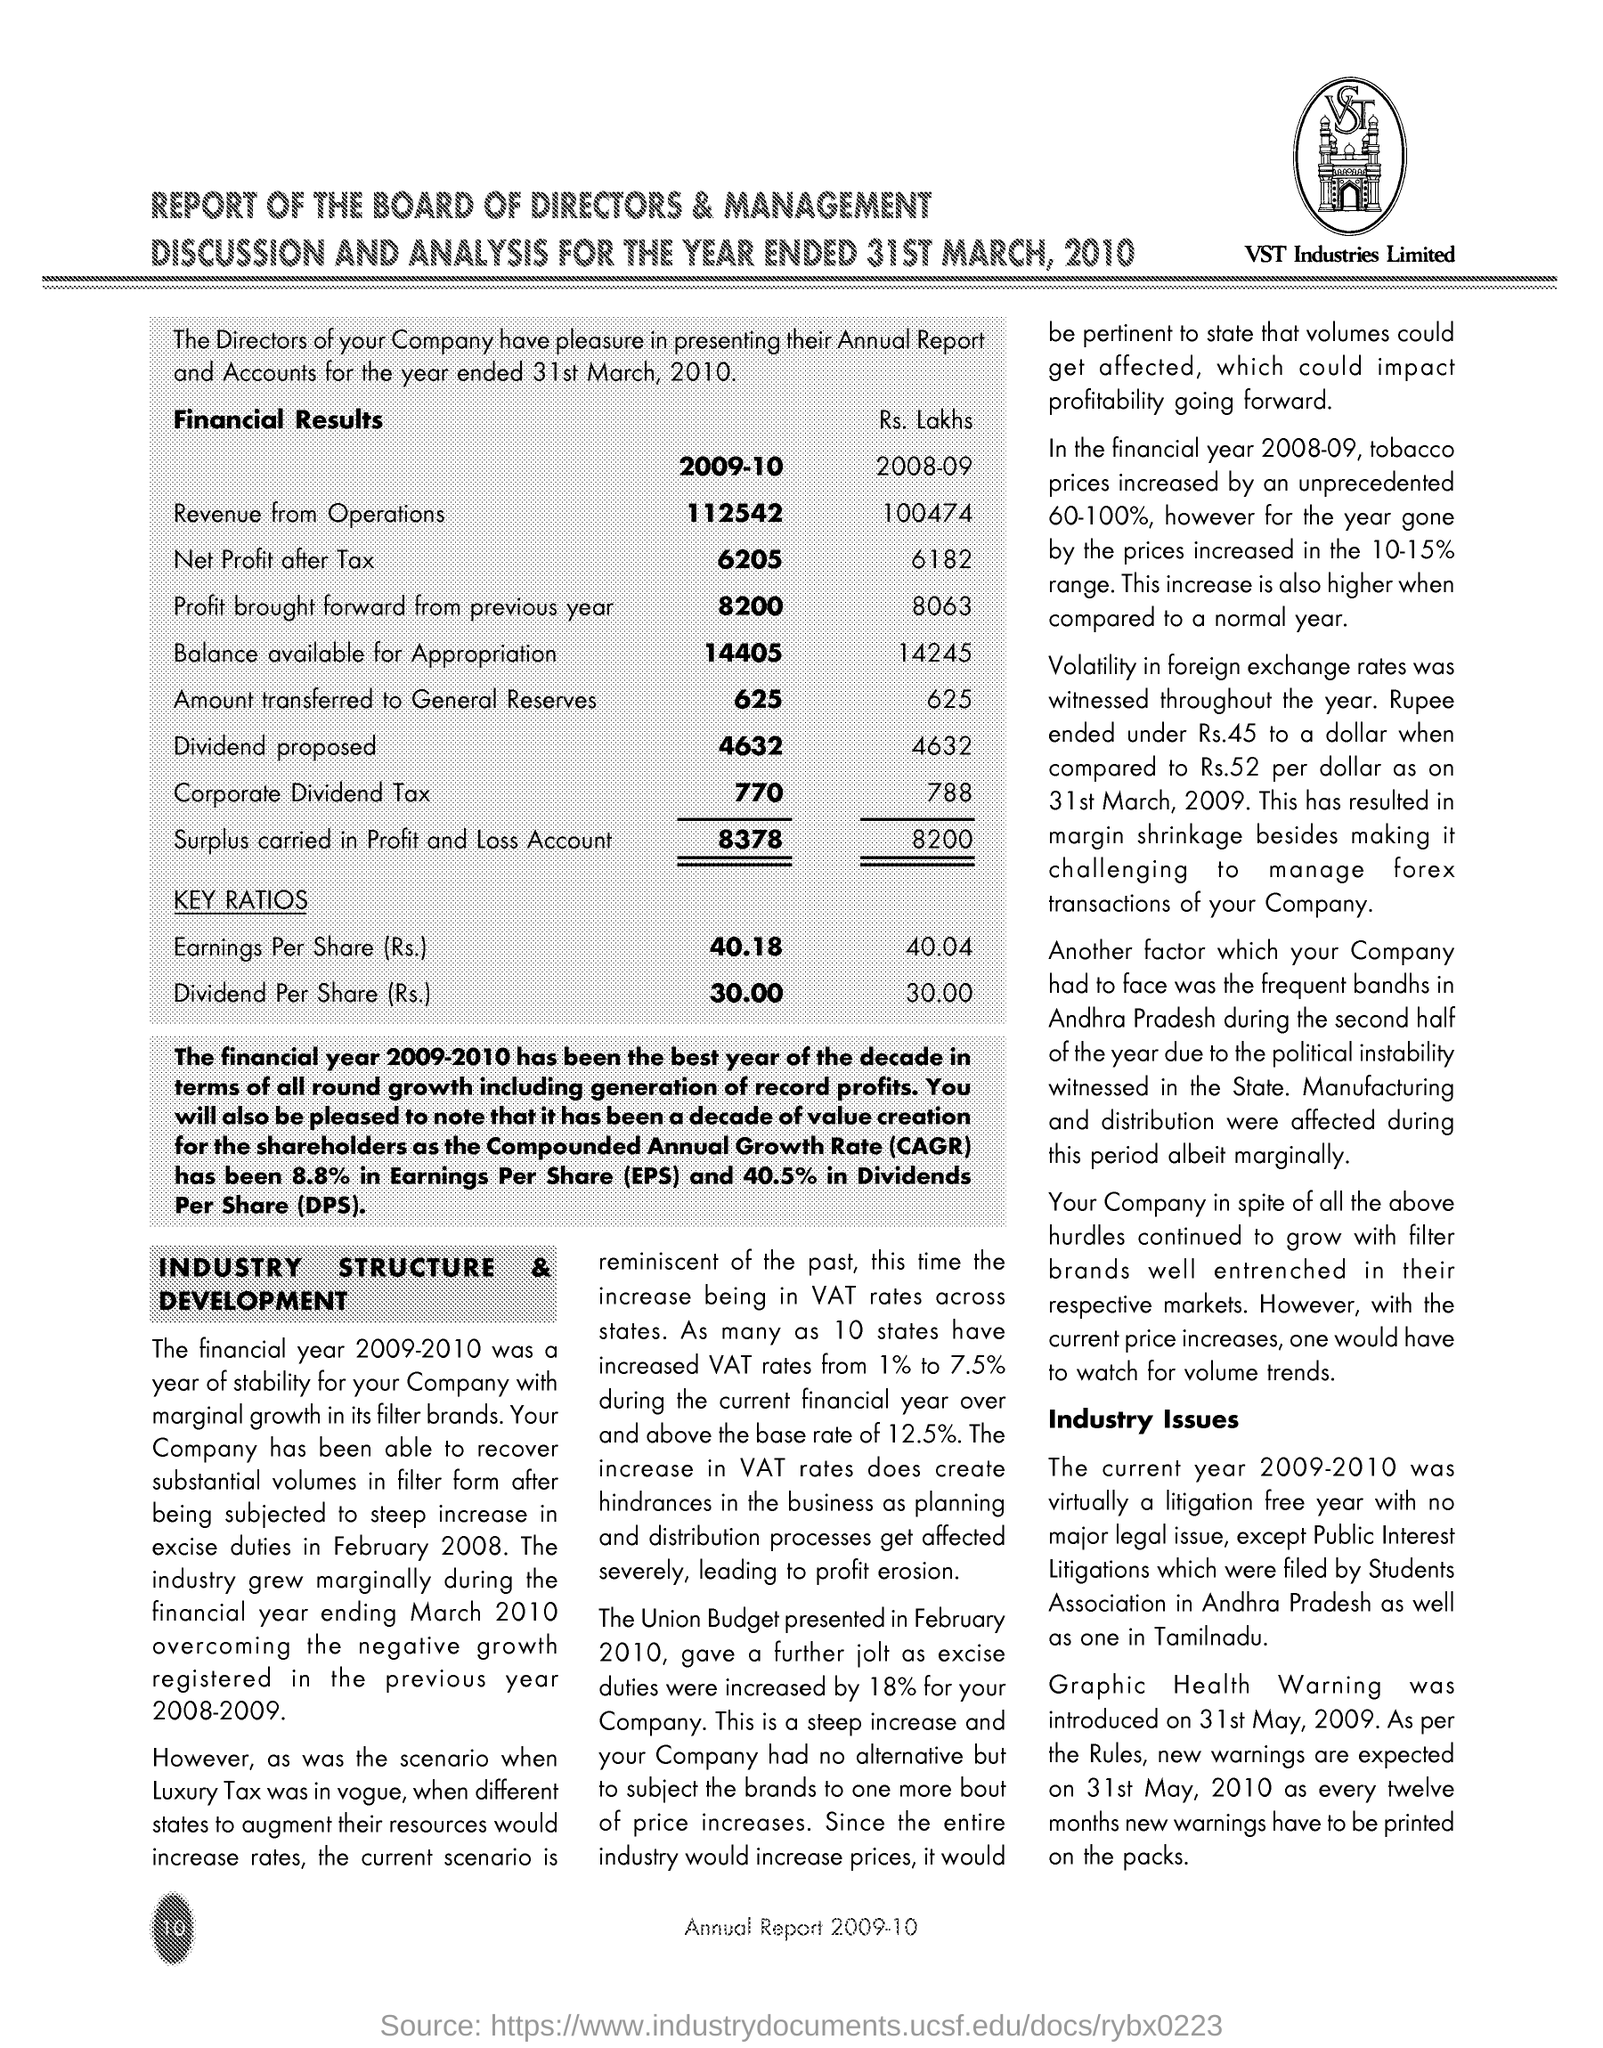What is the Company Name ?
Make the answer very short. VST Industries Limited. What is the Fullform of DPS ?
Provide a short and direct response. Dividends Per Share. What is the Fullform of EPS ?
Ensure brevity in your answer.  Earnings per share. How Much Amount Transferred to General Reserves in 2009-10 ?
Offer a very short reply. 625. What is the Fullform of CAGR ?
Ensure brevity in your answer.  Compounded annual growth rate. 